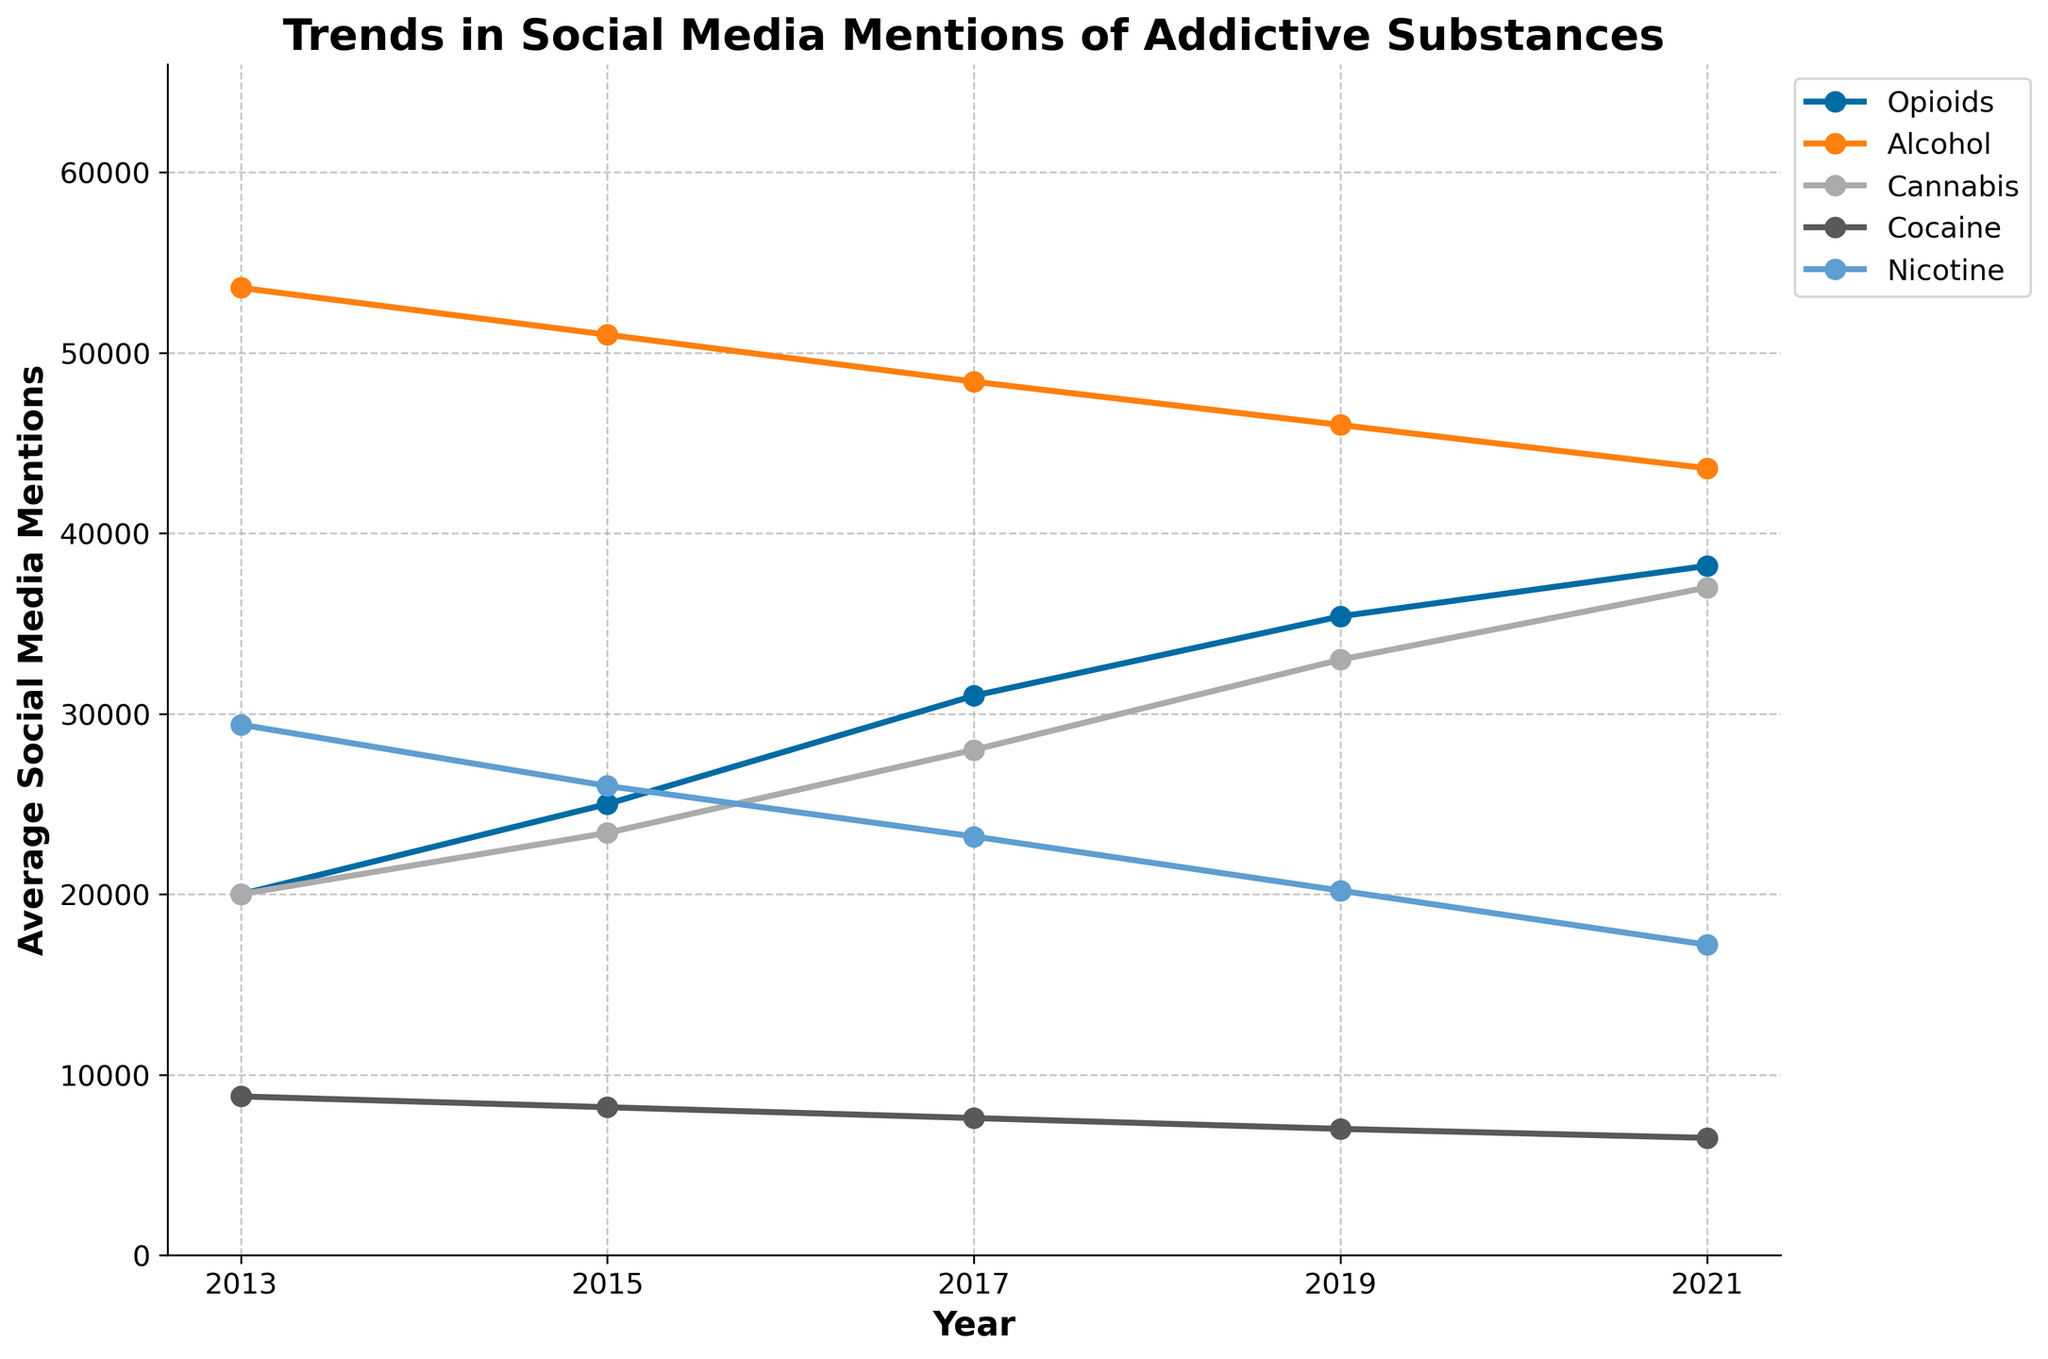What addictive substance had the highest social media mentions on average in 2019? To identify the substance with the highest mentions, observe the lines for each substance in 2019 and compare their y-values. The substance with the highest y-value is the answer.
Answer: Opioids Which age group mentioned Cannabis the most in 2021? Look for the line segment for Cannabis in 2021 and find the highest point among the age groups. The corresponding age group is the answer.
Answer: 18-24 What is the difference in social media mentions of Cocaine between the 18-24 and 55+ age groups in 2017? Find the y-values for Cocaine in 2017 for both age groups and calculate the difference: 7000 (18-24) - 4000 (55+).
Answer: 3000 Between the years 2013 and 2021, which substance shows the most significant overall increase in social media mentions? Track the ending y-values for each substance in 2021 and compare them to their starting y-values in 2013. The substance with the highest positive difference indicates the greatest increase.
Answer: Cannabis How did the social media mentions of Nicotine trend for the 25-34 age group over the years? Follow the trend line for Nicotine for the 25-34 age group across the years; observe if it's generally increasing, decreasing, or stable.
Answer: Decreasing In what year did Alcohol have the lowest average social media mentions? Examine the average y-values for Alcohol for each year; identify the year with the smallest value.
Answer: 2021 What is the combined total of social media mentions for Opioids and Cannabis for the 35-44 age group in 2019? Find the y-values for Opioids and Cannabis in 2019 for the 35-44 age group (40000 and 30000, respectively) and add them together: 40000 + 30000.
Answer: 70000 Which substance experienced the largest drop in mentions from 2019 to 2021 in the 45-54 age group? Compare the y-values for each substance in 2019 and 2021 for the 45-54 age group; find the substance with the most considerable decrease: Cocaine (7500 to 7000).
Answer: Cocaine Compare the trend lines for Opioids and Cannabis. In terms of visual slope, which one had a steeper increase over the last decade? Observe the steepness (angle) of the trend lines for Opioids and Cannabis from 2013 to 2021. The steeper slope indicates a faster rate of increase.
Answer: Cannabis 